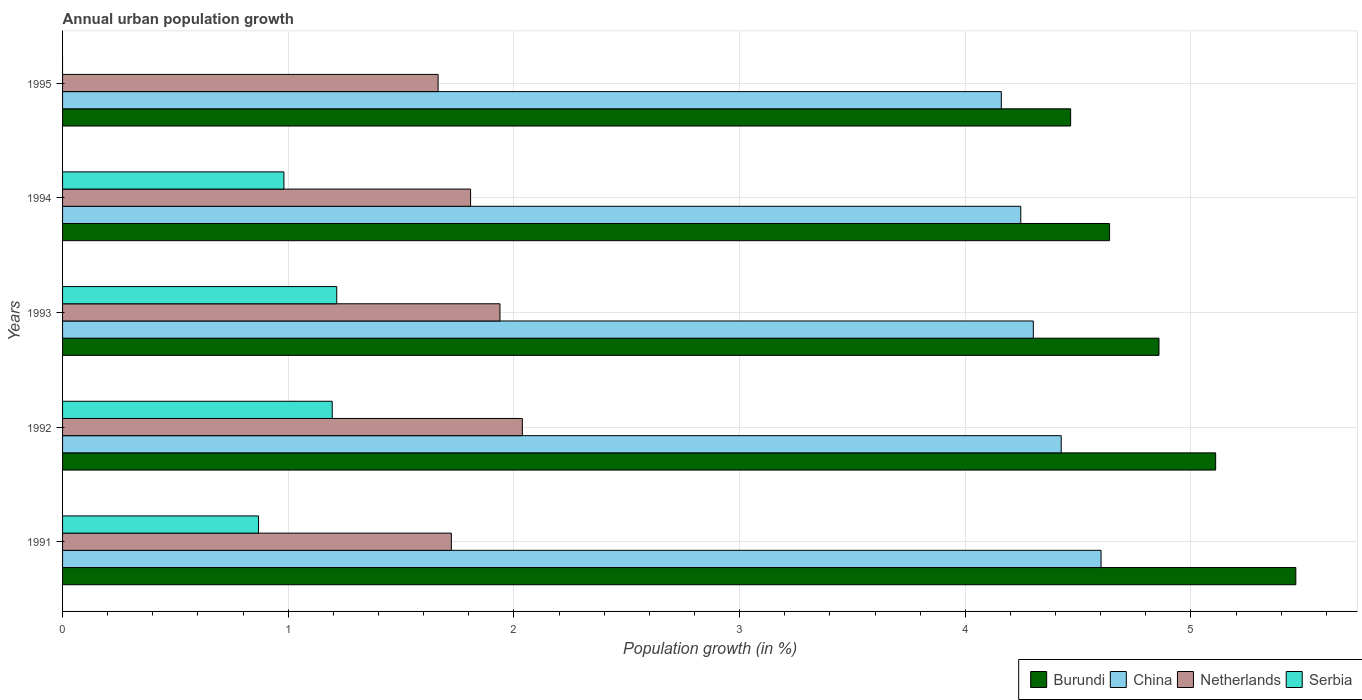Are the number of bars on each tick of the Y-axis equal?
Your response must be concise. No. How many bars are there on the 4th tick from the bottom?
Offer a terse response. 4. What is the percentage of urban population growth in Netherlands in 1991?
Your answer should be very brief. 1.72. Across all years, what is the maximum percentage of urban population growth in Netherlands?
Give a very brief answer. 2.04. What is the total percentage of urban population growth in Netherlands in the graph?
Your answer should be compact. 9.17. What is the difference between the percentage of urban population growth in Netherlands in 1991 and that in 1995?
Your answer should be compact. 0.06. What is the difference between the percentage of urban population growth in Burundi in 1994 and the percentage of urban population growth in China in 1993?
Ensure brevity in your answer.  0.34. What is the average percentage of urban population growth in Netherlands per year?
Make the answer very short. 1.83. In the year 1993, what is the difference between the percentage of urban population growth in China and percentage of urban population growth in Netherlands?
Your response must be concise. 2.36. What is the ratio of the percentage of urban population growth in China in 1992 to that in 1995?
Your answer should be very brief. 1.06. Is the percentage of urban population growth in Burundi in 1991 less than that in 1993?
Keep it short and to the point. No. Is the difference between the percentage of urban population growth in China in 1992 and 1993 greater than the difference between the percentage of urban population growth in Netherlands in 1992 and 1993?
Your answer should be very brief. Yes. What is the difference between the highest and the second highest percentage of urban population growth in Serbia?
Ensure brevity in your answer.  0.02. What is the difference between the highest and the lowest percentage of urban population growth in Burundi?
Make the answer very short. 1. In how many years, is the percentage of urban population growth in Serbia greater than the average percentage of urban population growth in Serbia taken over all years?
Give a very brief answer. 4. Is the sum of the percentage of urban population growth in China in 1993 and 1994 greater than the maximum percentage of urban population growth in Burundi across all years?
Ensure brevity in your answer.  Yes. Is it the case that in every year, the sum of the percentage of urban population growth in Serbia and percentage of urban population growth in China is greater than the sum of percentage of urban population growth in Netherlands and percentage of urban population growth in Burundi?
Give a very brief answer. Yes. How many bars are there?
Keep it short and to the point. 19. Are all the bars in the graph horizontal?
Offer a very short reply. Yes. How many years are there in the graph?
Your answer should be compact. 5. Does the graph contain grids?
Give a very brief answer. Yes. Where does the legend appear in the graph?
Offer a very short reply. Bottom right. How are the legend labels stacked?
Make the answer very short. Horizontal. What is the title of the graph?
Give a very brief answer. Annual urban population growth. Does "Argentina" appear as one of the legend labels in the graph?
Make the answer very short. No. What is the label or title of the X-axis?
Your answer should be very brief. Population growth (in %). What is the Population growth (in %) in Burundi in 1991?
Your answer should be compact. 5.46. What is the Population growth (in %) of China in 1991?
Provide a short and direct response. 4.6. What is the Population growth (in %) in Netherlands in 1991?
Offer a terse response. 1.72. What is the Population growth (in %) of Serbia in 1991?
Ensure brevity in your answer.  0.87. What is the Population growth (in %) in Burundi in 1992?
Provide a short and direct response. 5.11. What is the Population growth (in %) in China in 1992?
Your response must be concise. 4.43. What is the Population growth (in %) in Netherlands in 1992?
Make the answer very short. 2.04. What is the Population growth (in %) of Serbia in 1992?
Offer a very short reply. 1.19. What is the Population growth (in %) of Burundi in 1993?
Ensure brevity in your answer.  4.86. What is the Population growth (in %) of China in 1993?
Your answer should be very brief. 4.3. What is the Population growth (in %) of Netherlands in 1993?
Offer a terse response. 1.94. What is the Population growth (in %) in Serbia in 1993?
Provide a short and direct response. 1.21. What is the Population growth (in %) of Burundi in 1994?
Provide a succinct answer. 4.64. What is the Population growth (in %) in China in 1994?
Provide a short and direct response. 4.25. What is the Population growth (in %) of Netherlands in 1994?
Make the answer very short. 1.81. What is the Population growth (in %) of Serbia in 1994?
Your response must be concise. 0.98. What is the Population growth (in %) in Burundi in 1995?
Keep it short and to the point. 4.47. What is the Population growth (in %) in China in 1995?
Give a very brief answer. 4.16. What is the Population growth (in %) in Netherlands in 1995?
Give a very brief answer. 1.66. Across all years, what is the maximum Population growth (in %) of Burundi?
Your answer should be compact. 5.46. Across all years, what is the maximum Population growth (in %) in China?
Ensure brevity in your answer.  4.6. Across all years, what is the maximum Population growth (in %) in Netherlands?
Give a very brief answer. 2.04. Across all years, what is the maximum Population growth (in %) in Serbia?
Your response must be concise. 1.21. Across all years, what is the minimum Population growth (in %) in Burundi?
Your answer should be compact. 4.47. Across all years, what is the minimum Population growth (in %) in China?
Your answer should be very brief. 4.16. Across all years, what is the minimum Population growth (in %) of Netherlands?
Offer a terse response. 1.66. Across all years, what is the minimum Population growth (in %) of Serbia?
Keep it short and to the point. 0. What is the total Population growth (in %) of Burundi in the graph?
Provide a succinct answer. 24.54. What is the total Population growth (in %) in China in the graph?
Your response must be concise. 21.73. What is the total Population growth (in %) of Netherlands in the graph?
Give a very brief answer. 9.17. What is the total Population growth (in %) of Serbia in the graph?
Offer a terse response. 4.26. What is the difference between the Population growth (in %) in Burundi in 1991 and that in 1992?
Give a very brief answer. 0.36. What is the difference between the Population growth (in %) in China in 1991 and that in 1992?
Offer a very short reply. 0.18. What is the difference between the Population growth (in %) in Netherlands in 1991 and that in 1992?
Provide a short and direct response. -0.31. What is the difference between the Population growth (in %) in Serbia in 1991 and that in 1992?
Keep it short and to the point. -0.33. What is the difference between the Population growth (in %) in Burundi in 1991 and that in 1993?
Make the answer very short. 0.61. What is the difference between the Population growth (in %) in China in 1991 and that in 1993?
Your answer should be compact. 0.3. What is the difference between the Population growth (in %) in Netherlands in 1991 and that in 1993?
Make the answer very short. -0.22. What is the difference between the Population growth (in %) of Serbia in 1991 and that in 1993?
Keep it short and to the point. -0.35. What is the difference between the Population growth (in %) in Burundi in 1991 and that in 1994?
Provide a short and direct response. 0.83. What is the difference between the Population growth (in %) in China in 1991 and that in 1994?
Your answer should be very brief. 0.36. What is the difference between the Population growth (in %) in Netherlands in 1991 and that in 1994?
Your answer should be very brief. -0.09. What is the difference between the Population growth (in %) of Serbia in 1991 and that in 1994?
Ensure brevity in your answer.  -0.11. What is the difference between the Population growth (in %) in Burundi in 1991 and that in 1995?
Your answer should be compact. 1. What is the difference between the Population growth (in %) of China in 1991 and that in 1995?
Make the answer very short. 0.44. What is the difference between the Population growth (in %) in Netherlands in 1991 and that in 1995?
Make the answer very short. 0.06. What is the difference between the Population growth (in %) of Burundi in 1992 and that in 1993?
Give a very brief answer. 0.25. What is the difference between the Population growth (in %) in China in 1992 and that in 1993?
Give a very brief answer. 0.12. What is the difference between the Population growth (in %) in Netherlands in 1992 and that in 1993?
Make the answer very short. 0.1. What is the difference between the Population growth (in %) of Serbia in 1992 and that in 1993?
Ensure brevity in your answer.  -0.02. What is the difference between the Population growth (in %) in Burundi in 1992 and that in 1994?
Your answer should be very brief. 0.47. What is the difference between the Population growth (in %) in China in 1992 and that in 1994?
Your answer should be very brief. 0.18. What is the difference between the Population growth (in %) of Netherlands in 1992 and that in 1994?
Offer a terse response. 0.23. What is the difference between the Population growth (in %) in Serbia in 1992 and that in 1994?
Make the answer very short. 0.21. What is the difference between the Population growth (in %) in Burundi in 1992 and that in 1995?
Your answer should be compact. 0.64. What is the difference between the Population growth (in %) of China in 1992 and that in 1995?
Provide a succinct answer. 0.27. What is the difference between the Population growth (in %) in Netherlands in 1992 and that in 1995?
Provide a succinct answer. 0.37. What is the difference between the Population growth (in %) in Burundi in 1993 and that in 1994?
Ensure brevity in your answer.  0.22. What is the difference between the Population growth (in %) in China in 1993 and that in 1994?
Keep it short and to the point. 0.06. What is the difference between the Population growth (in %) of Netherlands in 1993 and that in 1994?
Your answer should be compact. 0.13. What is the difference between the Population growth (in %) of Serbia in 1993 and that in 1994?
Provide a short and direct response. 0.23. What is the difference between the Population growth (in %) in Burundi in 1993 and that in 1995?
Offer a very short reply. 0.39. What is the difference between the Population growth (in %) of China in 1993 and that in 1995?
Offer a terse response. 0.14. What is the difference between the Population growth (in %) of Netherlands in 1993 and that in 1995?
Your answer should be very brief. 0.27. What is the difference between the Population growth (in %) in Burundi in 1994 and that in 1995?
Offer a very short reply. 0.17. What is the difference between the Population growth (in %) of China in 1994 and that in 1995?
Your response must be concise. 0.09. What is the difference between the Population growth (in %) of Netherlands in 1994 and that in 1995?
Offer a terse response. 0.14. What is the difference between the Population growth (in %) of Burundi in 1991 and the Population growth (in %) of China in 1992?
Ensure brevity in your answer.  1.04. What is the difference between the Population growth (in %) of Burundi in 1991 and the Population growth (in %) of Netherlands in 1992?
Provide a short and direct response. 3.43. What is the difference between the Population growth (in %) of Burundi in 1991 and the Population growth (in %) of Serbia in 1992?
Your answer should be compact. 4.27. What is the difference between the Population growth (in %) in China in 1991 and the Population growth (in %) in Netherlands in 1992?
Make the answer very short. 2.56. What is the difference between the Population growth (in %) of China in 1991 and the Population growth (in %) of Serbia in 1992?
Provide a short and direct response. 3.41. What is the difference between the Population growth (in %) of Netherlands in 1991 and the Population growth (in %) of Serbia in 1992?
Give a very brief answer. 0.53. What is the difference between the Population growth (in %) of Burundi in 1991 and the Population growth (in %) of China in 1993?
Offer a terse response. 1.16. What is the difference between the Population growth (in %) of Burundi in 1991 and the Population growth (in %) of Netherlands in 1993?
Ensure brevity in your answer.  3.53. What is the difference between the Population growth (in %) of Burundi in 1991 and the Population growth (in %) of Serbia in 1993?
Provide a succinct answer. 4.25. What is the difference between the Population growth (in %) of China in 1991 and the Population growth (in %) of Netherlands in 1993?
Your answer should be very brief. 2.66. What is the difference between the Population growth (in %) in China in 1991 and the Population growth (in %) in Serbia in 1993?
Keep it short and to the point. 3.39. What is the difference between the Population growth (in %) in Netherlands in 1991 and the Population growth (in %) in Serbia in 1993?
Ensure brevity in your answer.  0.51. What is the difference between the Population growth (in %) in Burundi in 1991 and the Population growth (in %) in China in 1994?
Your response must be concise. 1.22. What is the difference between the Population growth (in %) of Burundi in 1991 and the Population growth (in %) of Netherlands in 1994?
Provide a succinct answer. 3.66. What is the difference between the Population growth (in %) of Burundi in 1991 and the Population growth (in %) of Serbia in 1994?
Ensure brevity in your answer.  4.48. What is the difference between the Population growth (in %) in China in 1991 and the Population growth (in %) in Netherlands in 1994?
Offer a terse response. 2.79. What is the difference between the Population growth (in %) in China in 1991 and the Population growth (in %) in Serbia in 1994?
Keep it short and to the point. 3.62. What is the difference between the Population growth (in %) in Netherlands in 1991 and the Population growth (in %) in Serbia in 1994?
Offer a very short reply. 0.74. What is the difference between the Population growth (in %) of Burundi in 1991 and the Population growth (in %) of China in 1995?
Make the answer very short. 1.31. What is the difference between the Population growth (in %) in Burundi in 1991 and the Population growth (in %) in Netherlands in 1995?
Give a very brief answer. 3.8. What is the difference between the Population growth (in %) of China in 1991 and the Population growth (in %) of Netherlands in 1995?
Give a very brief answer. 2.94. What is the difference between the Population growth (in %) of Burundi in 1992 and the Population growth (in %) of China in 1993?
Make the answer very short. 0.81. What is the difference between the Population growth (in %) in Burundi in 1992 and the Population growth (in %) in Netherlands in 1993?
Give a very brief answer. 3.17. What is the difference between the Population growth (in %) in Burundi in 1992 and the Population growth (in %) in Serbia in 1993?
Give a very brief answer. 3.89. What is the difference between the Population growth (in %) in China in 1992 and the Population growth (in %) in Netherlands in 1993?
Your answer should be compact. 2.49. What is the difference between the Population growth (in %) in China in 1992 and the Population growth (in %) in Serbia in 1993?
Keep it short and to the point. 3.21. What is the difference between the Population growth (in %) in Netherlands in 1992 and the Population growth (in %) in Serbia in 1993?
Provide a short and direct response. 0.82. What is the difference between the Population growth (in %) of Burundi in 1992 and the Population growth (in %) of China in 1994?
Offer a very short reply. 0.86. What is the difference between the Population growth (in %) of Burundi in 1992 and the Population growth (in %) of Netherlands in 1994?
Provide a short and direct response. 3.3. What is the difference between the Population growth (in %) of Burundi in 1992 and the Population growth (in %) of Serbia in 1994?
Your answer should be very brief. 4.13. What is the difference between the Population growth (in %) in China in 1992 and the Population growth (in %) in Netherlands in 1994?
Offer a terse response. 2.62. What is the difference between the Population growth (in %) in China in 1992 and the Population growth (in %) in Serbia in 1994?
Your answer should be very brief. 3.44. What is the difference between the Population growth (in %) in Netherlands in 1992 and the Population growth (in %) in Serbia in 1994?
Keep it short and to the point. 1.06. What is the difference between the Population growth (in %) in Burundi in 1992 and the Population growth (in %) in China in 1995?
Provide a succinct answer. 0.95. What is the difference between the Population growth (in %) in Burundi in 1992 and the Population growth (in %) in Netherlands in 1995?
Provide a succinct answer. 3.45. What is the difference between the Population growth (in %) of China in 1992 and the Population growth (in %) of Netherlands in 1995?
Provide a short and direct response. 2.76. What is the difference between the Population growth (in %) of Burundi in 1993 and the Population growth (in %) of China in 1994?
Ensure brevity in your answer.  0.61. What is the difference between the Population growth (in %) of Burundi in 1993 and the Population growth (in %) of Netherlands in 1994?
Keep it short and to the point. 3.05. What is the difference between the Population growth (in %) in Burundi in 1993 and the Population growth (in %) in Serbia in 1994?
Ensure brevity in your answer.  3.88. What is the difference between the Population growth (in %) of China in 1993 and the Population growth (in %) of Netherlands in 1994?
Your response must be concise. 2.49. What is the difference between the Population growth (in %) of China in 1993 and the Population growth (in %) of Serbia in 1994?
Give a very brief answer. 3.32. What is the difference between the Population growth (in %) of Netherlands in 1993 and the Population growth (in %) of Serbia in 1994?
Keep it short and to the point. 0.96. What is the difference between the Population growth (in %) in Burundi in 1993 and the Population growth (in %) in China in 1995?
Offer a very short reply. 0.7. What is the difference between the Population growth (in %) in Burundi in 1993 and the Population growth (in %) in Netherlands in 1995?
Provide a short and direct response. 3.19. What is the difference between the Population growth (in %) in China in 1993 and the Population growth (in %) in Netherlands in 1995?
Keep it short and to the point. 2.64. What is the difference between the Population growth (in %) of Burundi in 1994 and the Population growth (in %) of China in 1995?
Ensure brevity in your answer.  0.48. What is the difference between the Population growth (in %) in Burundi in 1994 and the Population growth (in %) in Netherlands in 1995?
Give a very brief answer. 2.98. What is the difference between the Population growth (in %) of China in 1994 and the Population growth (in %) of Netherlands in 1995?
Offer a terse response. 2.58. What is the average Population growth (in %) in Burundi per year?
Offer a terse response. 4.91. What is the average Population growth (in %) in China per year?
Your answer should be very brief. 4.35. What is the average Population growth (in %) of Netherlands per year?
Ensure brevity in your answer.  1.83. What is the average Population growth (in %) of Serbia per year?
Your answer should be very brief. 0.85. In the year 1991, what is the difference between the Population growth (in %) of Burundi and Population growth (in %) of China?
Your response must be concise. 0.86. In the year 1991, what is the difference between the Population growth (in %) of Burundi and Population growth (in %) of Netherlands?
Your response must be concise. 3.74. In the year 1991, what is the difference between the Population growth (in %) in Burundi and Population growth (in %) in Serbia?
Ensure brevity in your answer.  4.6. In the year 1991, what is the difference between the Population growth (in %) in China and Population growth (in %) in Netherlands?
Your answer should be compact. 2.88. In the year 1991, what is the difference between the Population growth (in %) in China and Population growth (in %) in Serbia?
Your response must be concise. 3.73. In the year 1991, what is the difference between the Population growth (in %) of Netherlands and Population growth (in %) of Serbia?
Your response must be concise. 0.85. In the year 1992, what is the difference between the Population growth (in %) in Burundi and Population growth (in %) in China?
Your response must be concise. 0.68. In the year 1992, what is the difference between the Population growth (in %) of Burundi and Population growth (in %) of Netherlands?
Offer a very short reply. 3.07. In the year 1992, what is the difference between the Population growth (in %) of Burundi and Population growth (in %) of Serbia?
Provide a succinct answer. 3.91. In the year 1992, what is the difference between the Population growth (in %) in China and Population growth (in %) in Netherlands?
Ensure brevity in your answer.  2.39. In the year 1992, what is the difference between the Population growth (in %) of China and Population growth (in %) of Serbia?
Give a very brief answer. 3.23. In the year 1992, what is the difference between the Population growth (in %) in Netherlands and Population growth (in %) in Serbia?
Your response must be concise. 0.84. In the year 1993, what is the difference between the Population growth (in %) of Burundi and Population growth (in %) of China?
Offer a very short reply. 0.56. In the year 1993, what is the difference between the Population growth (in %) of Burundi and Population growth (in %) of Netherlands?
Offer a very short reply. 2.92. In the year 1993, what is the difference between the Population growth (in %) of Burundi and Population growth (in %) of Serbia?
Offer a very short reply. 3.64. In the year 1993, what is the difference between the Population growth (in %) in China and Population growth (in %) in Netherlands?
Your answer should be compact. 2.36. In the year 1993, what is the difference between the Population growth (in %) of China and Population growth (in %) of Serbia?
Provide a short and direct response. 3.09. In the year 1993, what is the difference between the Population growth (in %) of Netherlands and Population growth (in %) of Serbia?
Offer a terse response. 0.72. In the year 1994, what is the difference between the Population growth (in %) of Burundi and Population growth (in %) of China?
Your answer should be very brief. 0.39. In the year 1994, what is the difference between the Population growth (in %) of Burundi and Population growth (in %) of Netherlands?
Provide a succinct answer. 2.83. In the year 1994, what is the difference between the Population growth (in %) of Burundi and Population growth (in %) of Serbia?
Keep it short and to the point. 3.66. In the year 1994, what is the difference between the Population growth (in %) of China and Population growth (in %) of Netherlands?
Provide a succinct answer. 2.44. In the year 1994, what is the difference between the Population growth (in %) of China and Population growth (in %) of Serbia?
Your response must be concise. 3.27. In the year 1994, what is the difference between the Population growth (in %) of Netherlands and Population growth (in %) of Serbia?
Offer a very short reply. 0.83. In the year 1995, what is the difference between the Population growth (in %) of Burundi and Population growth (in %) of China?
Your answer should be compact. 0.31. In the year 1995, what is the difference between the Population growth (in %) of Burundi and Population growth (in %) of Netherlands?
Make the answer very short. 2.8. In the year 1995, what is the difference between the Population growth (in %) of China and Population growth (in %) of Netherlands?
Offer a terse response. 2.5. What is the ratio of the Population growth (in %) of Burundi in 1991 to that in 1992?
Ensure brevity in your answer.  1.07. What is the ratio of the Population growth (in %) of China in 1991 to that in 1992?
Offer a terse response. 1.04. What is the ratio of the Population growth (in %) in Netherlands in 1991 to that in 1992?
Your response must be concise. 0.85. What is the ratio of the Population growth (in %) of Serbia in 1991 to that in 1992?
Give a very brief answer. 0.73. What is the ratio of the Population growth (in %) in Burundi in 1991 to that in 1993?
Your answer should be very brief. 1.12. What is the ratio of the Population growth (in %) of China in 1991 to that in 1993?
Keep it short and to the point. 1.07. What is the ratio of the Population growth (in %) of Serbia in 1991 to that in 1993?
Make the answer very short. 0.71. What is the ratio of the Population growth (in %) of Burundi in 1991 to that in 1994?
Provide a short and direct response. 1.18. What is the ratio of the Population growth (in %) of China in 1991 to that in 1994?
Your answer should be very brief. 1.08. What is the ratio of the Population growth (in %) in Netherlands in 1991 to that in 1994?
Offer a very short reply. 0.95. What is the ratio of the Population growth (in %) in Serbia in 1991 to that in 1994?
Your response must be concise. 0.89. What is the ratio of the Population growth (in %) in Burundi in 1991 to that in 1995?
Give a very brief answer. 1.22. What is the ratio of the Population growth (in %) in China in 1991 to that in 1995?
Make the answer very short. 1.11. What is the ratio of the Population growth (in %) of Netherlands in 1991 to that in 1995?
Your response must be concise. 1.04. What is the ratio of the Population growth (in %) of Burundi in 1992 to that in 1993?
Provide a short and direct response. 1.05. What is the ratio of the Population growth (in %) of China in 1992 to that in 1993?
Your response must be concise. 1.03. What is the ratio of the Population growth (in %) of Netherlands in 1992 to that in 1993?
Offer a very short reply. 1.05. What is the ratio of the Population growth (in %) of Serbia in 1992 to that in 1993?
Your response must be concise. 0.98. What is the ratio of the Population growth (in %) of Burundi in 1992 to that in 1994?
Your answer should be very brief. 1.1. What is the ratio of the Population growth (in %) in China in 1992 to that in 1994?
Make the answer very short. 1.04. What is the ratio of the Population growth (in %) of Netherlands in 1992 to that in 1994?
Ensure brevity in your answer.  1.13. What is the ratio of the Population growth (in %) of Serbia in 1992 to that in 1994?
Your response must be concise. 1.22. What is the ratio of the Population growth (in %) in Burundi in 1992 to that in 1995?
Ensure brevity in your answer.  1.14. What is the ratio of the Population growth (in %) of China in 1992 to that in 1995?
Offer a terse response. 1.06. What is the ratio of the Population growth (in %) of Netherlands in 1992 to that in 1995?
Make the answer very short. 1.22. What is the ratio of the Population growth (in %) of Burundi in 1993 to that in 1994?
Your answer should be compact. 1.05. What is the ratio of the Population growth (in %) in China in 1993 to that in 1994?
Your answer should be compact. 1.01. What is the ratio of the Population growth (in %) in Netherlands in 1993 to that in 1994?
Your answer should be very brief. 1.07. What is the ratio of the Population growth (in %) in Serbia in 1993 to that in 1994?
Your response must be concise. 1.24. What is the ratio of the Population growth (in %) of Burundi in 1993 to that in 1995?
Your answer should be compact. 1.09. What is the ratio of the Population growth (in %) of China in 1993 to that in 1995?
Make the answer very short. 1.03. What is the ratio of the Population growth (in %) in Netherlands in 1993 to that in 1995?
Your response must be concise. 1.16. What is the ratio of the Population growth (in %) in Burundi in 1994 to that in 1995?
Your answer should be very brief. 1.04. What is the ratio of the Population growth (in %) of China in 1994 to that in 1995?
Offer a very short reply. 1.02. What is the ratio of the Population growth (in %) in Netherlands in 1994 to that in 1995?
Give a very brief answer. 1.09. What is the difference between the highest and the second highest Population growth (in %) in Burundi?
Your response must be concise. 0.36. What is the difference between the highest and the second highest Population growth (in %) of China?
Keep it short and to the point. 0.18. What is the difference between the highest and the second highest Population growth (in %) of Netherlands?
Offer a terse response. 0.1. What is the difference between the highest and the second highest Population growth (in %) in Serbia?
Keep it short and to the point. 0.02. What is the difference between the highest and the lowest Population growth (in %) of China?
Ensure brevity in your answer.  0.44. What is the difference between the highest and the lowest Population growth (in %) of Netherlands?
Your answer should be compact. 0.37. What is the difference between the highest and the lowest Population growth (in %) of Serbia?
Offer a terse response. 1.21. 